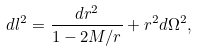Convert formula to latex. <formula><loc_0><loc_0><loc_500><loc_500>d l ^ { 2 } = \frac { d r ^ { 2 } } { 1 - 2 M / r } + r ^ { 2 } d \Omega ^ { 2 } ,</formula> 